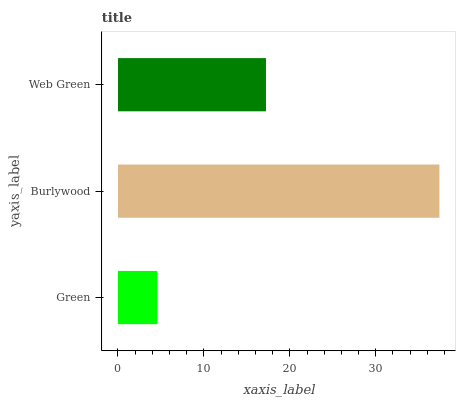Is Green the minimum?
Answer yes or no. Yes. Is Burlywood the maximum?
Answer yes or no. Yes. Is Web Green the minimum?
Answer yes or no. No. Is Web Green the maximum?
Answer yes or no. No. Is Burlywood greater than Web Green?
Answer yes or no. Yes. Is Web Green less than Burlywood?
Answer yes or no. Yes. Is Web Green greater than Burlywood?
Answer yes or no. No. Is Burlywood less than Web Green?
Answer yes or no. No. Is Web Green the high median?
Answer yes or no. Yes. Is Web Green the low median?
Answer yes or no. Yes. Is Green the high median?
Answer yes or no. No. Is Green the low median?
Answer yes or no. No. 